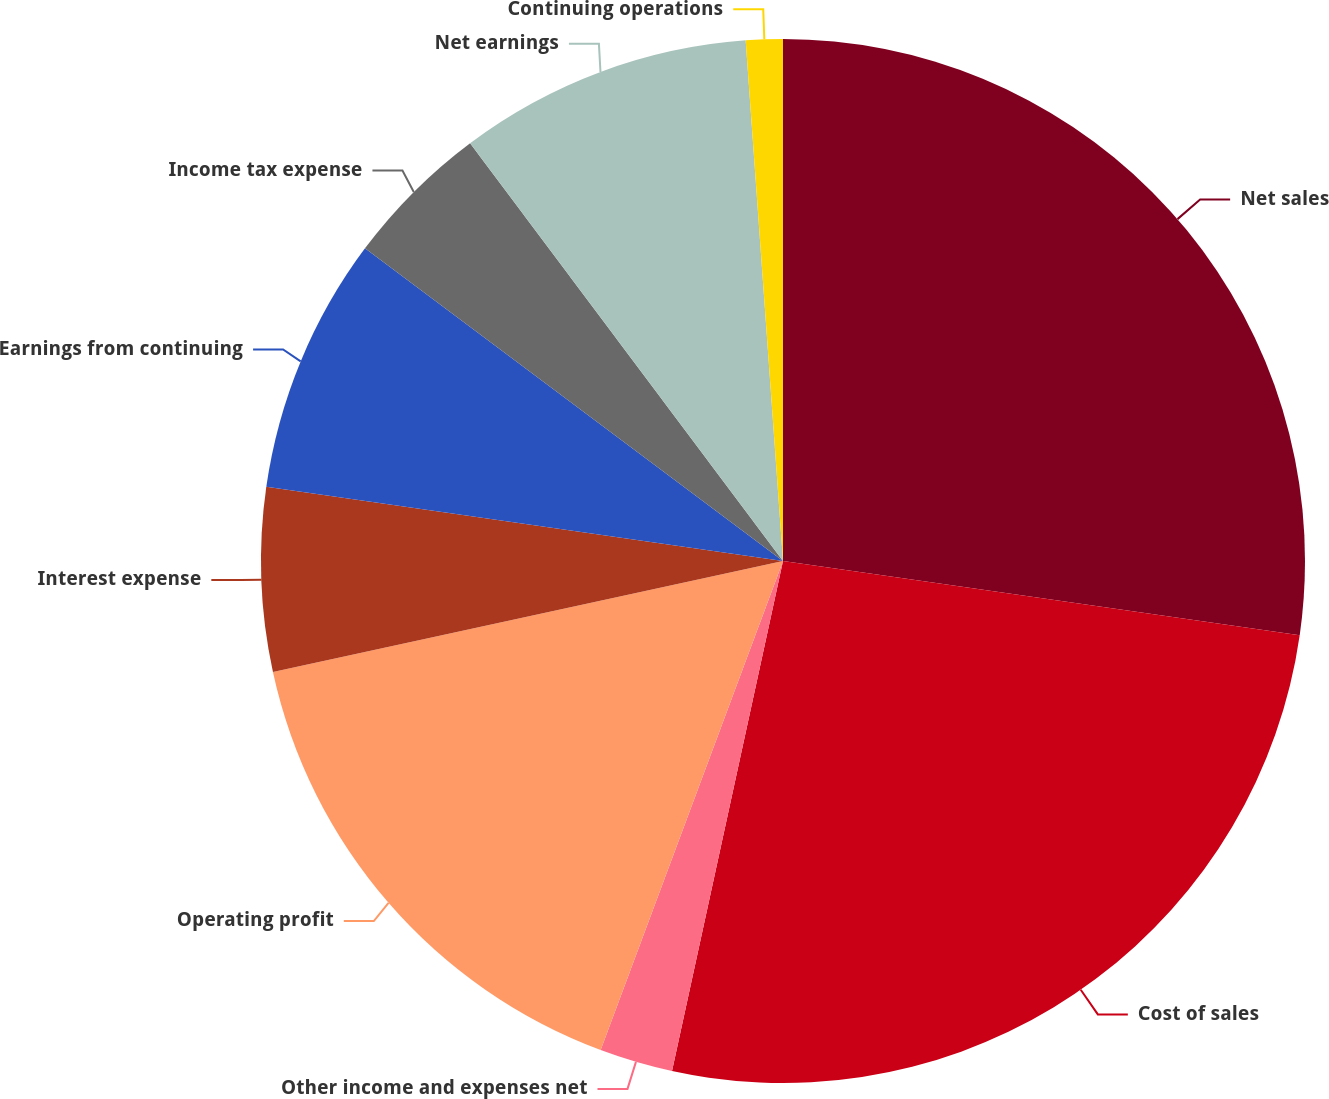Convert chart. <chart><loc_0><loc_0><loc_500><loc_500><pie_chart><fcel>Net sales<fcel>Cost of sales<fcel>Other income and expenses net<fcel>Operating profit<fcel>Interest expense<fcel>Earnings from continuing<fcel>Income tax expense<fcel>Net earnings<fcel>Continuing operations<nl><fcel>27.27%<fcel>26.14%<fcel>2.27%<fcel>15.91%<fcel>5.68%<fcel>7.95%<fcel>4.55%<fcel>9.09%<fcel>1.14%<nl></chart> 